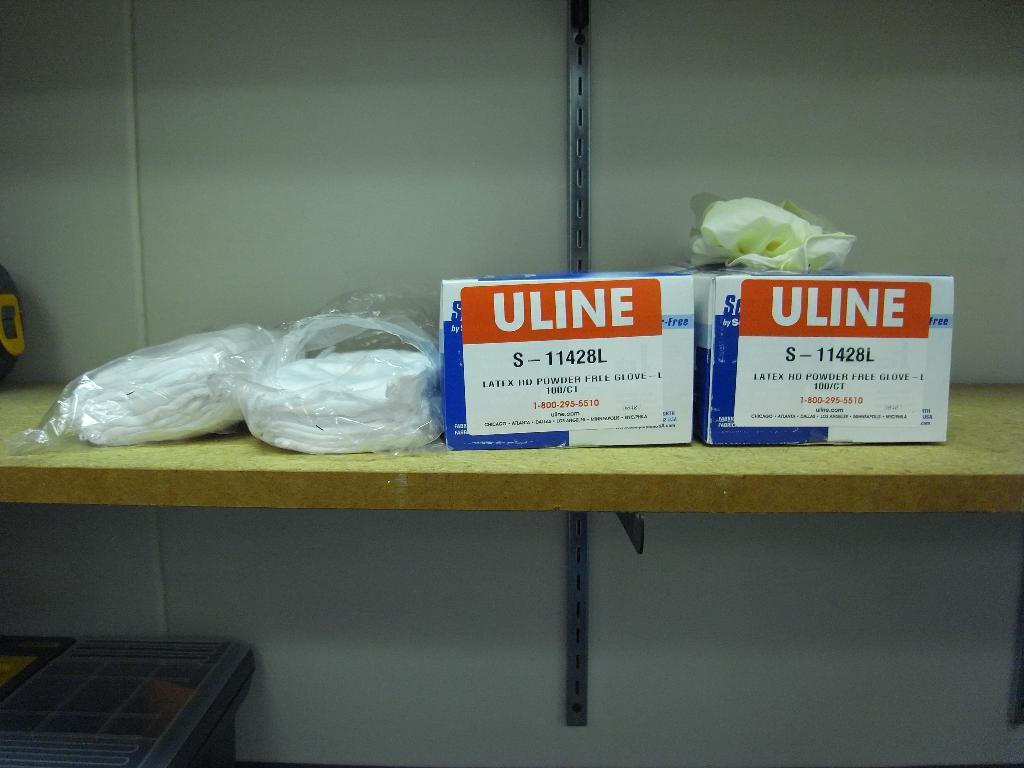How would you summarize this image in a sentence or two? In this image I can see there are two boxes with orange color stickers on them, on the left side there are clothes in polythene covers. 